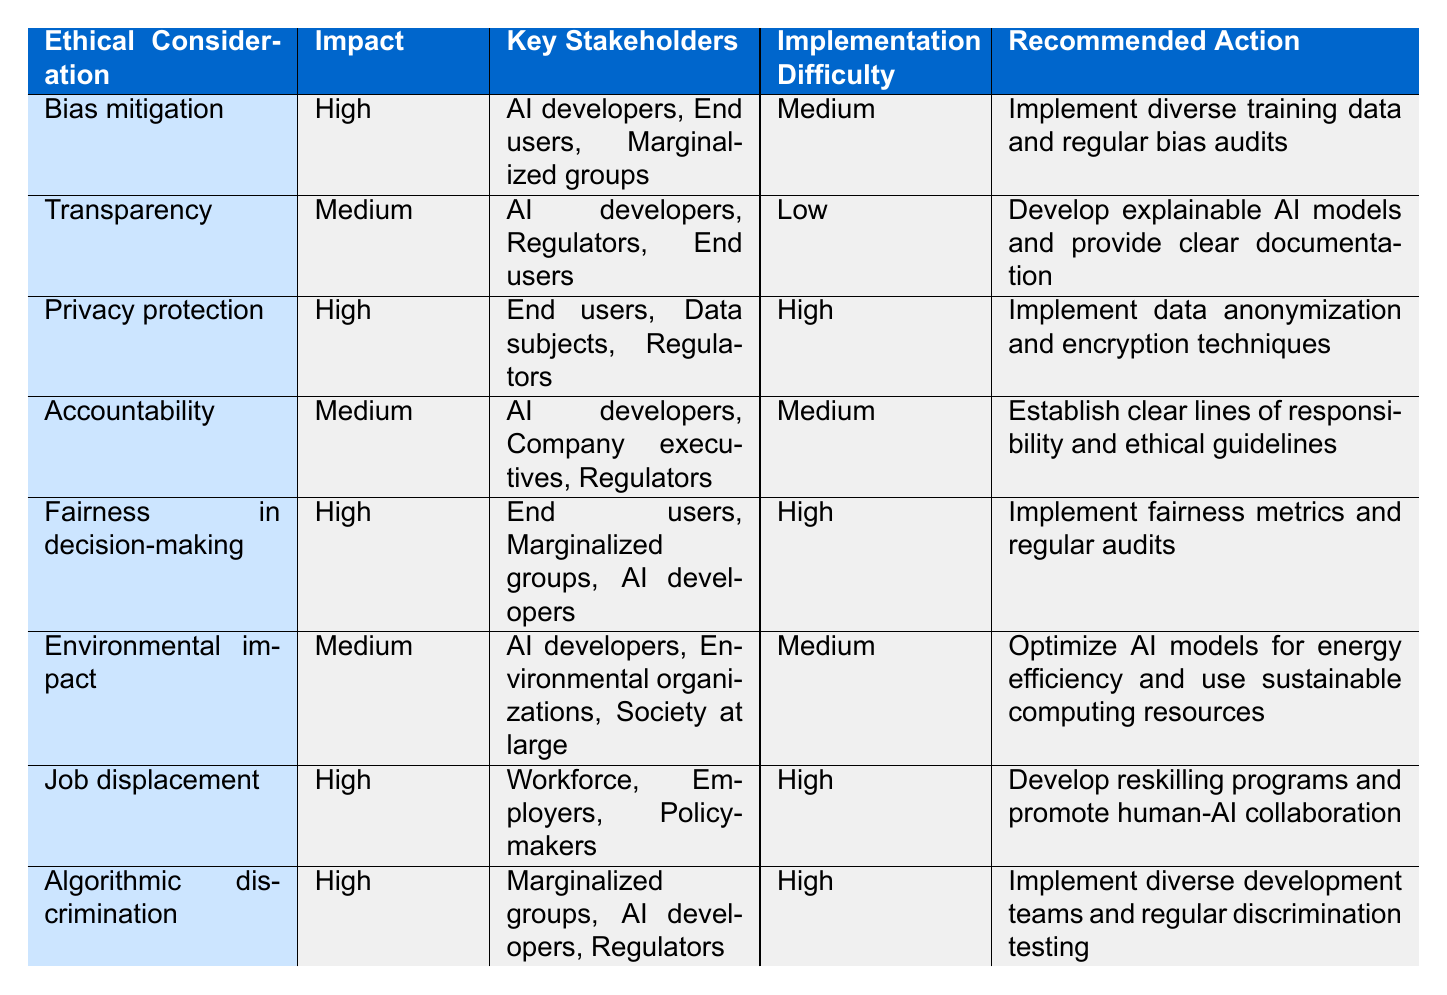What is the recommended action for bias mitigation? The recommended action for bias mitigation is provided in the corresponding row in the table. By scanning down the "Recommended Action" column for the "Bias mitigation" row, we find that it states "Implement diverse training data and regular bias audits."
Answer: Implement diverse training data and regular bias audits Which ethical consideration has the highest impact? By reviewing the "Impact" column in the table, we look for the highest value, which is indicated as "High." Several considerations have a "High" impact, including "Bias mitigation," "Privacy protection," "Fairness in decision-making," "Job displacement," and "Algorithmic discrimination."
Answer: Bias mitigation, Privacy protection, Fairness in decision-making, Job displacement, Algorithmic discrimination Is the implementation difficulty for transparency high? To answer this, we check the "Implementation Difficulty" column for the "Transparency" row, which lists it as "Low." Since the question asks for high difficulty, and it states low, the answer is straightforward.
Answer: No Which stakeholders are involved in job displacement? We find the "Job displacement" row in the table and look at the "Key Stakeholders" column, which lists "Workforce," "Employers," and "Policymakers." This gives us the needed stakeholders.
Answer: Workforce, Employers, Policymakers What is the total number of ethical considerations listed in the table? The total number of ethical considerations can be calculated by counting the number of rows in the table that detail each consideration. There are eight rows, reflecting eight different considerations for ethical actions in AI.
Answer: 8 Which ethical consideration has a medium implementation difficulty and involves environmental organizations? To find the answer, we first filter the table by "Implementation Difficulty" as "Medium" and look specifically for a consideration that includes "Environmental organizations" as a stakeholder. Scanning the rows confirms that "Environmental impact" fits this criteria.
Answer: Environmental impact How many ethical considerations are related to marginalized groups? We evaluate the "Key Stakeholders" column for each row, specifically counting the entries mentioning "Marginalized groups." The rows for "Bias mitigation," "Fairness in decision-making," and "Algorithmic discrimination" all mention marginalized groups, accumulating to three considerations.
Answer: 3 Is the recommended action for privacy protection implementing diverse training data? Referring to the "Privacy protection" row in the table, the recommended action stated there is "Implement data anonymization and encryption techniques." The question asks whether it involves diverse training data, which is not the case here.
Answer: No 